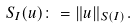Convert formula to latex. <formula><loc_0><loc_0><loc_500><loc_500>S _ { I } ( u ) \colon = \| u \| _ { S ( I ) } .</formula> 